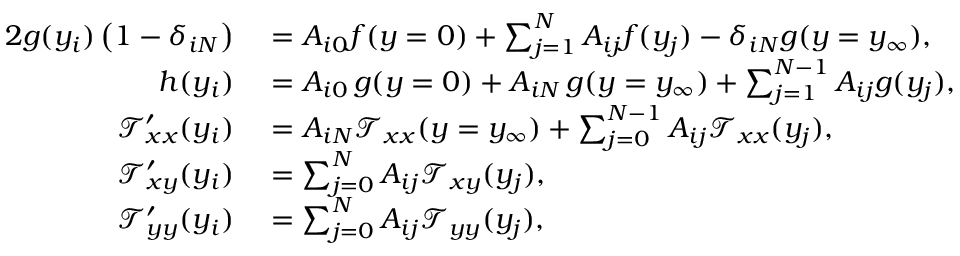Convert formula to latex. <formula><loc_0><loc_0><loc_500><loc_500>\begin{array} { r l r l } { { 2 } g ( y _ { i } ) \left ( 1 - \delta _ { i N } \right ) } & = A _ { i 0 } f ( y = 0 ) + \sum _ { j = 1 } ^ { N } A _ { i j } f ( y _ { j } ) - \delta _ { i N } g ( y = y _ { \infty } ) , \quad } & i = 1 , \dots , N } \\ { h ( y _ { i } ) } & = A _ { i 0 } \, g ( y = 0 ) + A _ { i N } \, g ( y = y _ { \infty } ) + \sum _ { j = 1 } ^ { N - 1 } A _ { i j } g ( y _ { j } ) , \quad } & i = 1 , \dots , N - 1 } \\ { \mathcal { T } _ { x x } ^ { \prime } ( y _ { i } ) } & = A _ { i N } \mathcal { T } _ { x x } ( y = y _ { \infty } ) + \sum _ { j = 0 } ^ { N - 1 } A _ { i j } \mathcal { T } _ { x x } ( y _ { j } ) , \quad } & i = 0 , \dots , N - 1 . } \\ { \mathcal { T } _ { x y } ^ { \prime } ( y _ { i } ) } & = \sum _ { j = 0 } ^ { N } A _ { i j } \mathcal { T } _ { x y } ( y _ { j } ) , \quad } & i = 0 , \dots , N - 1 . } \\ { \mathcal { T } _ { y y } ^ { \prime } ( y _ { i } ) } & = \sum _ { j = 0 } ^ { N } A _ { i j } \mathcal { T } _ { y y } ( y _ { j } ) , \quad } & i = 0 , \dots , N - 1 , } \end{array}</formula> 